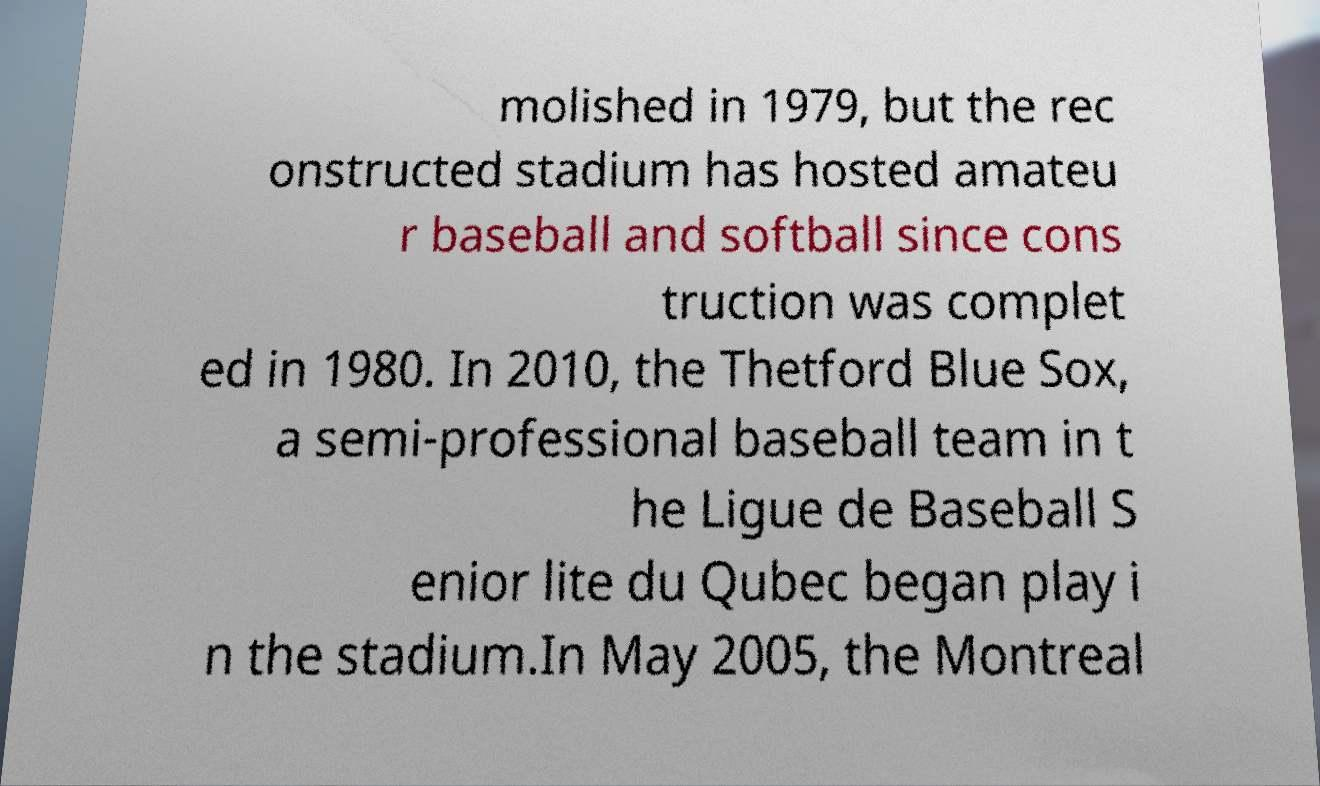Can you read and provide the text displayed in the image?This photo seems to have some interesting text. Can you extract and type it out for me? molished in 1979, but the rec onstructed stadium has hosted amateu r baseball and softball since cons truction was complet ed in 1980. In 2010, the Thetford Blue Sox, a semi-professional baseball team in t he Ligue de Baseball S enior lite du Qubec began play i n the stadium.In May 2005, the Montreal 